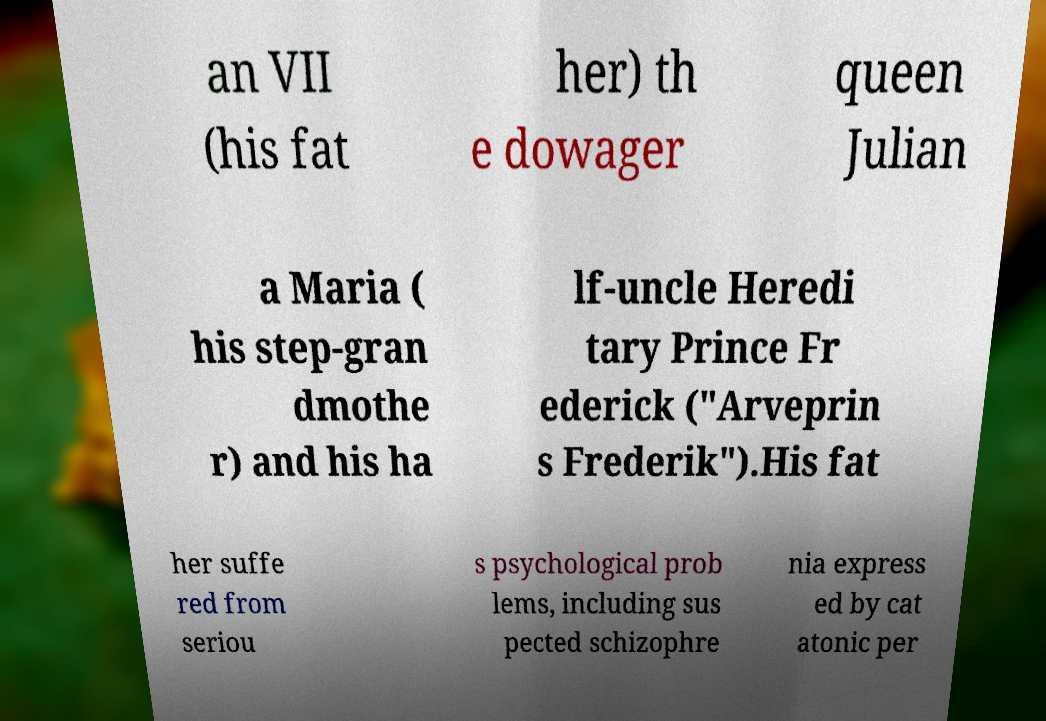Could you extract and type out the text from this image? an VII (his fat her) th e dowager queen Julian a Maria ( his step-gran dmothe r) and his ha lf-uncle Heredi tary Prince Fr ederick ("Arveprin s Frederik").His fat her suffe red from seriou s psychological prob lems, including sus pected schizophre nia express ed by cat atonic per 